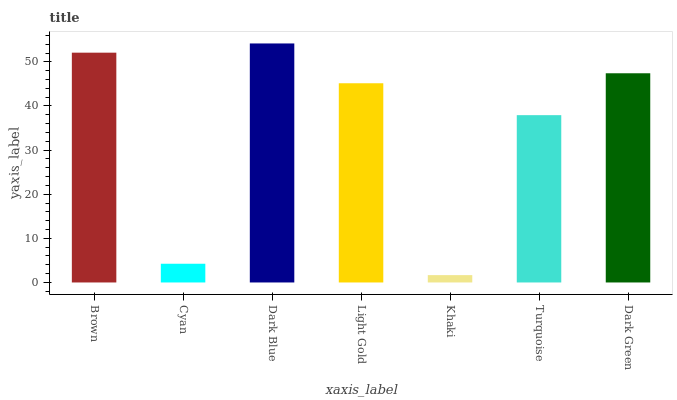Is Khaki the minimum?
Answer yes or no. Yes. Is Dark Blue the maximum?
Answer yes or no. Yes. Is Cyan the minimum?
Answer yes or no. No. Is Cyan the maximum?
Answer yes or no. No. Is Brown greater than Cyan?
Answer yes or no. Yes. Is Cyan less than Brown?
Answer yes or no. Yes. Is Cyan greater than Brown?
Answer yes or no. No. Is Brown less than Cyan?
Answer yes or no. No. Is Light Gold the high median?
Answer yes or no. Yes. Is Light Gold the low median?
Answer yes or no. Yes. Is Khaki the high median?
Answer yes or no. No. Is Cyan the low median?
Answer yes or no. No. 